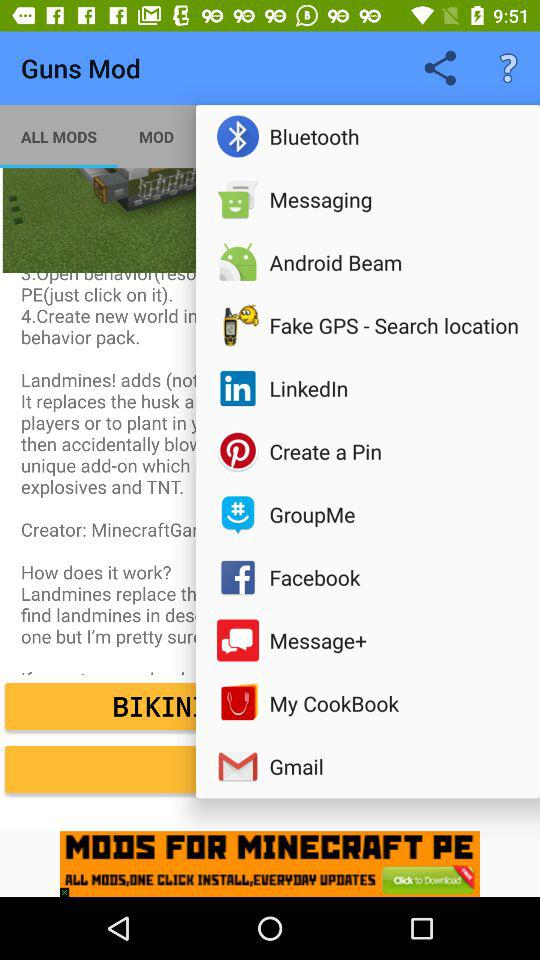What are the sharing options? The sharing options are "Bluetooth", "Messaging", "Android Beam", "Fake GPS - Search location", "LinkedIn", "Create a Pin", "GroupMe", "Facebook", "Message+", "My CookBook" and "Gmail". 